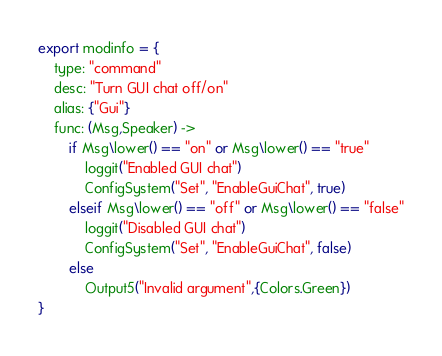Convert code to text. <code><loc_0><loc_0><loc_500><loc_500><_MoonScript_>export modinfo = {
	type: "command"
	desc: "Turn GUI chat off/on"
	alias: {"Gui"}
	func: (Msg,Speaker) ->
		if Msg\lower() == "on" or Msg\lower() == "true"
			loggit("Enabled GUI chat")
			ConfigSystem("Set", "EnableGuiChat", true)
		elseif Msg\lower() == "off" or Msg\lower() == "false"
			loggit("Disabled GUI chat")
			ConfigSystem("Set", "EnableGuiChat", false)
		else
			Output5("Invalid argument",{Colors.Green})
}</code> 